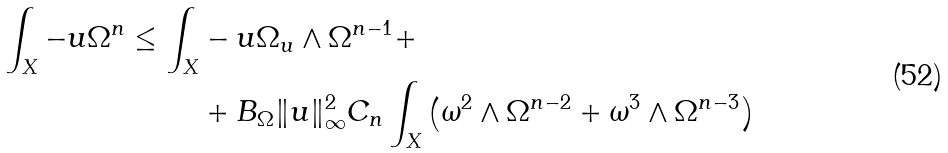Convert formula to latex. <formula><loc_0><loc_0><loc_500><loc_500>\int _ { X } - u \Omega ^ { n } \leq \int _ { X } & - u \Omega _ { u } \wedge \Omega ^ { n - 1 } + \\ & + B _ { \Omega } \| u \| _ { \infty } ^ { 2 } C _ { n } \int _ { X } \left ( \omega ^ { 2 } \wedge \Omega ^ { n - 2 } + \omega ^ { 3 } \wedge \Omega ^ { n - 3 } \right )</formula> 